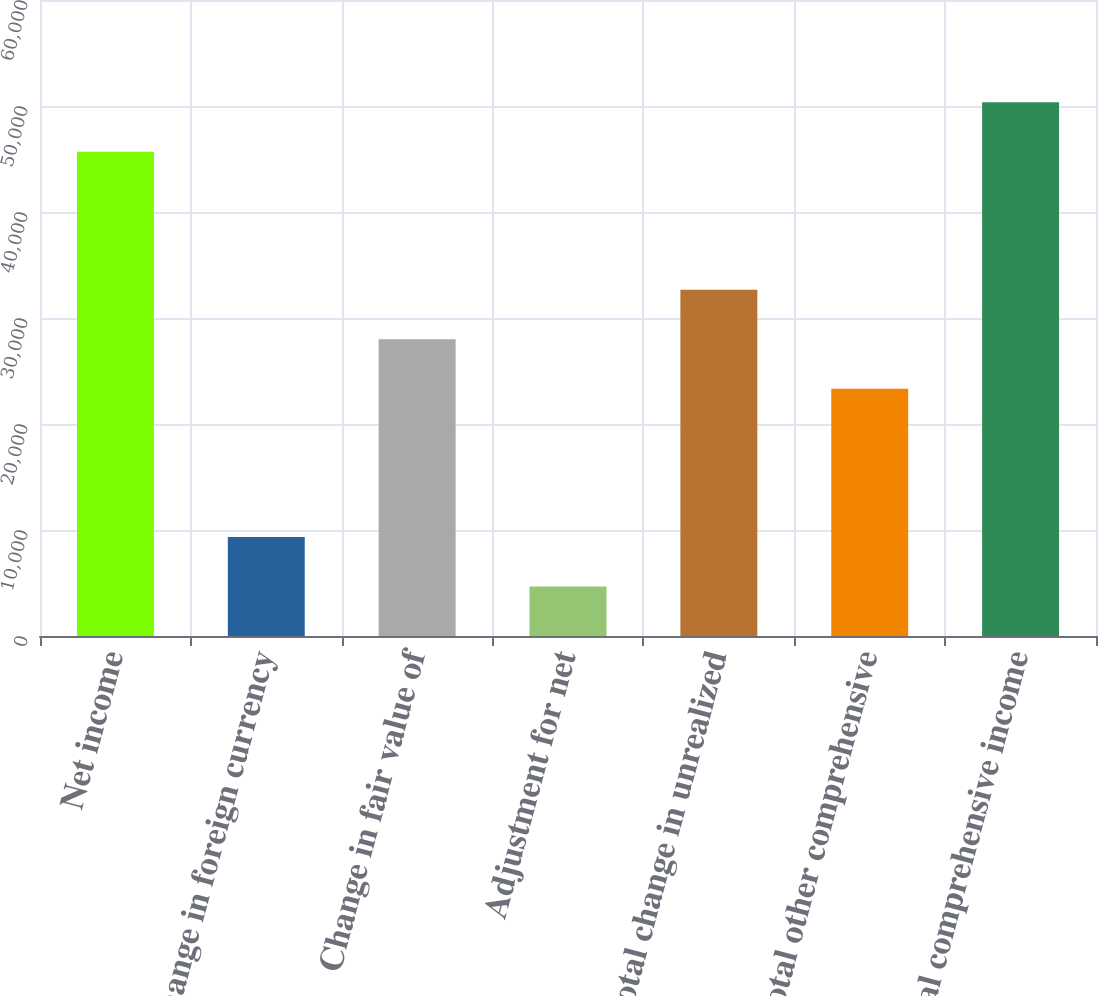Convert chart. <chart><loc_0><loc_0><loc_500><loc_500><bar_chart><fcel>Net income<fcel>Change in foreign currency<fcel>Change in fair value of<fcel>Adjustment for net<fcel>Total change in unrealized<fcel>Total other comprehensive<fcel>Total comprehensive income<nl><fcel>45687<fcel>9338.8<fcel>28002.4<fcel>4672.9<fcel>32668.3<fcel>23336.5<fcel>50352.9<nl></chart> 